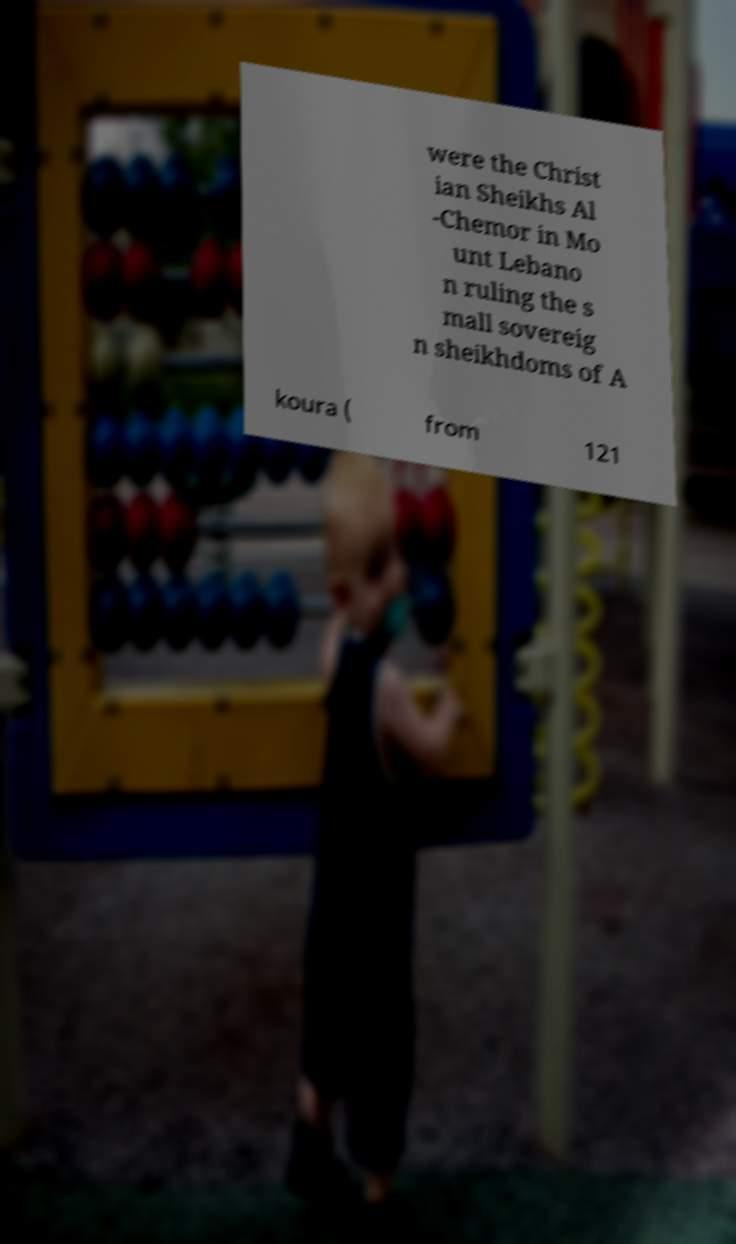Please identify and transcribe the text found in this image. were the Christ ian Sheikhs Al -Chemor in Mo unt Lebano n ruling the s mall sovereig n sheikhdoms of A koura ( from 121 